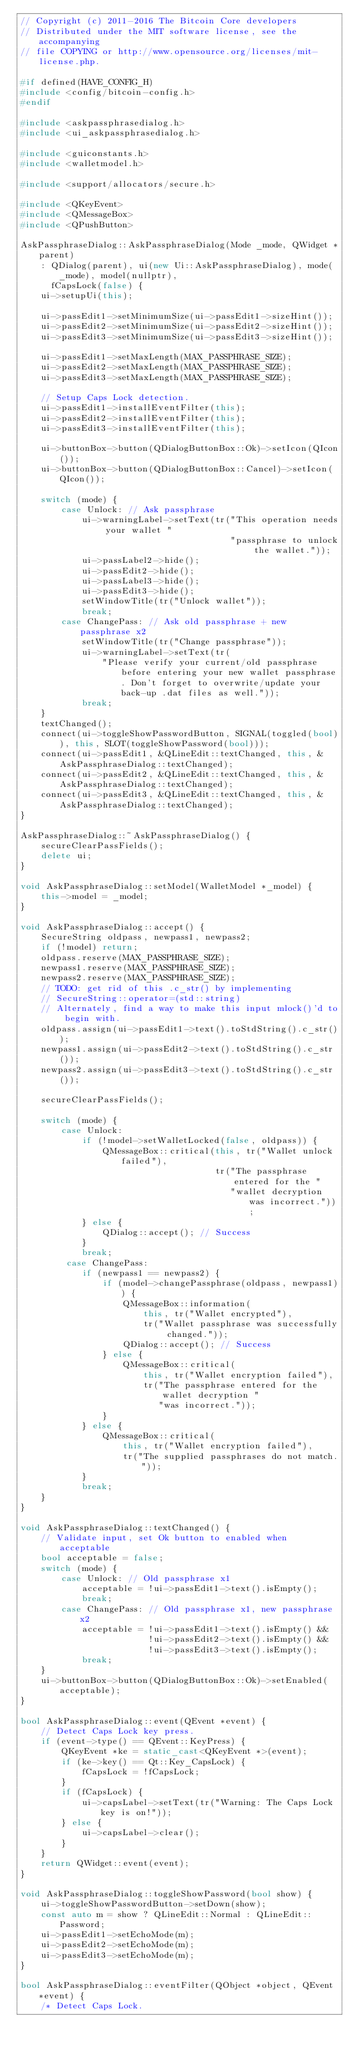Convert code to text. <code><loc_0><loc_0><loc_500><loc_500><_C++_>// Copyright (c) 2011-2016 The Bitcoin Core developers
// Distributed under the MIT software license, see the accompanying
// file COPYING or http://www.opensource.org/licenses/mit-license.php.

#if defined(HAVE_CONFIG_H)
#include <config/bitcoin-config.h>
#endif

#include <askpassphrasedialog.h>
#include <ui_askpassphrasedialog.h>

#include <guiconstants.h>
#include <walletmodel.h>

#include <support/allocators/secure.h>

#include <QKeyEvent>
#include <QMessageBox>
#include <QPushButton>

AskPassphraseDialog::AskPassphraseDialog(Mode _mode, QWidget *parent)
    : QDialog(parent), ui(new Ui::AskPassphraseDialog), mode(_mode), model(nullptr),
      fCapsLock(false) {
    ui->setupUi(this);

    ui->passEdit1->setMinimumSize(ui->passEdit1->sizeHint());
    ui->passEdit2->setMinimumSize(ui->passEdit2->sizeHint());
    ui->passEdit3->setMinimumSize(ui->passEdit3->sizeHint());

    ui->passEdit1->setMaxLength(MAX_PASSPHRASE_SIZE);
    ui->passEdit2->setMaxLength(MAX_PASSPHRASE_SIZE);
    ui->passEdit3->setMaxLength(MAX_PASSPHRASE_SIZE);

    // Setup Caps Lock detection.
    ui->passEdit1->installEventFilter(this);
    ui->passEdit2->installEventFilter(this);
    ui->passEdit3->installEventFilter(this);

    ui->buttonBox->button(QDialogButtonBox::Ok)->setIcon(QIcon());
    ui->buttonBox->button(QDialogButtonBox::Cancel)->setIcon(QIcon());

    switch (mode) {
        case Unlock: // Ask passphrase
            ui->warningLabel->setText(tr("This operation needs your wallet "
                                         "passphrase to unlock the wallet."));
            ui->passLabel2->hide();
            ui->passEdit2->hide();
            ui->passLabel3->hide();
            ui->passEdit3->hide();
            setWindowTitle(tr("Unlock wallet"));
            break;
        case ChangePass: // Ask old passphrase + new passphrase x2
            setWindowTitle(tr("Change passphrase"));
            ui->warningLabel->setText(tr(
                "Please verify your current/old passphrase before entering your new wallet passphrase. Don't forget to overwrite/update your back-up .dat files as well."));
            break;
    }
    textChanged();
    connect(ui->toggleShowPasswordButton, SIGNAL(toggled(bool)), this, SLOT(toggleShowPassword(bool)));
    connect(ui->passEdit1, &QLineEdit::textChanged, this, &AskPassphraseDialog::textChanged);
    connect(ui->passEdit2, &QLineEdit::textChanged, this, &AskPassphraseDialog::textChanged);
    connect(ui->passEdit3, &QLineEdit::textChanged, this, &AskPassphraseDialog::textChanged);
}

AskPassphraseDialog::~AskPassphraseDialog() {
    secureClearPassFields();
    delete ui;
}

void AskPassphraseDialog::setModel(WalletModel *_model) {
    this->model = _model;
}

void AskPassphraseDialog::accept() {
    SecureString oldpass, newpass1, newpass2;
    if (!model) return;
    oldpass.reserve(MAX_PASSPHRASE_SIZE);
    newpass1.reserve(MAX_PASSPHRASE_SIZE);
    newpass2.reserve(MAX_PASSPHRASE_SIZE);
    // TODO: get rid of this .c_str() by implementing
    // SecureString::operator=(std::string)
    // Alternately, find a way to make this input mlock()'d to begin with.
    oldpass.assign(ui->passEdit1->text().toStdString().c_str());
    newpass1.assign(ui->passEdit2->text().toStdString().c_str());
    newpass2.assign(ui->passEdit3->text().toStdString().c_str());

    secureClearPassFields();

    switch (mode) {
        case Unlock:
            if (!model->setWalletLocked(false, oldpass)) {
                QMessageBox::critical(this, tr("Wallet unlock failed"),
                                      tr("The passphrase entered for the "
                                         "wallet decryption was incorrect."));
            } else {
                QDialog::accept(); // Success
            }
            break;
         case ChangePass:
            if (newpass1 == newpass2) {
                if (model->changePassphrase(oldpass, newpass1)) {
                    QMessageBox::information(
                        this, tr("Wallet encrypted"),
                        tr("Wallet passphrase was successfully changed."));
                    QDialog::accept(); // Success
                } else {
                    QMessageBox::critical(
                        this, tr("Wallet encryption failed"),
                        tr("The passphrase entered for the wallet decryption "
                           "was incorrect."));
                }
            } else {
                QMessageBox::critical(
                    this, tr("Wallet encryption failed"),
                    tr("The supplied passphrases do not match."));
            }
            break;
    }
}

void AskPassphraseDialog::textChanged() {
    // Validate input, set Ok button to enabled when acceptable
    bool acceptable = false;
    switch (mode) {
        case Unlock: // Old passphrase x1
            acceptable = !ui->passEdit1->text().isEmpty();
            break;
        case ChangePass: // Old passphrase x1, new passphrase x2
            acceptable = !ui->passEdit1->text().isEmpty() &&
                         !ui->passEdit2->text().isEmpty() &&
                         !ui->passEdit3->text().isEmpty();
            break;
    }
    ui->buttonBox->button(QDialogButtonBox::Ok)->setEnabled(acceptable);
}

bool AskPassphraseDialog::event(QEvent *event) {
    // Detect Caps Lock key press.
    if (event->type() == QEvent::KeyPress) {
        QKeyEvent *ke = static_cast<QKeyEvent *>(event);
        if (ke->key() == Qt::Key_CapsLock) {
            fCapsLock = !fCapsLock;
        }
        if (fCapsLock) {
            ui->capsLabel->setText(tr("Warning: The Caps Lock key is on!"));
        } else {
            ui->capsLabel->clear();
        }
    }
    return QWidget::event(event);
}

void AskPassphraseDialog::toggleShowPassword(bool show) {
    ui->toggleShowPasswordButton->setDown(show);
    const auto m = show ? QLineEdit::Normal : QLineEdit::Password;
    ui->passEdit1->setEchoMode(m);
    ui->passEdit2->setEchoMode(m);
    ui->passEdit3->setEchoMode(m);
}

bool AskPassphraseDialog::eventFilter(QObject *object, QEvent *event) {
    /* Detect Caps Lock.</code> 